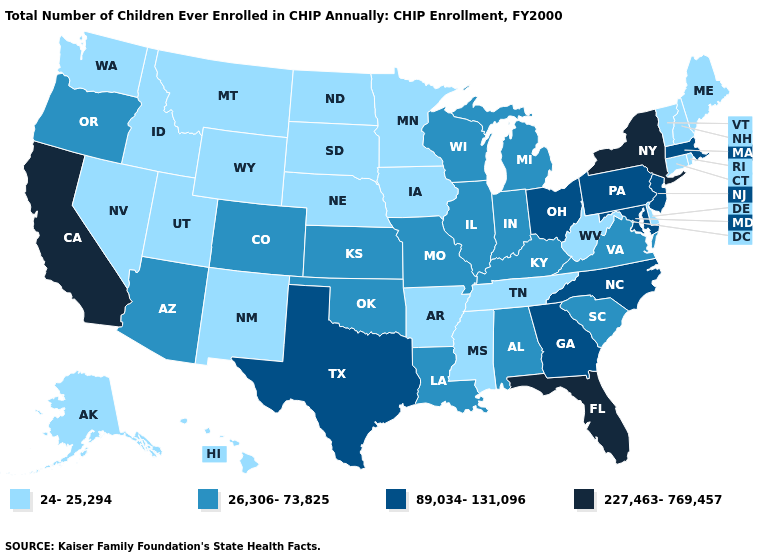Among the states that border Tennessee , does North Carolina have the highest value?
Write a very short answer. Yes. Name the states that have a value in the range 24-25,294?
Concise answer only. Alaska, Arkansas, Connecticut, Delaware, Hawaii, Idaho, Iowa, Maine, Minnesota, Mississippi, Montana, Nebraska, Nevada, New Hampshire, New Mexico, North Dakota, Rhode Island, South Dakota, Tennessee, Utah, Vermont, Washington, West Virginia, Wyoming. What is the lowest value in states that border Iowa?
Write a very short answer. 24-25,294. Does Kansas have the highest value in the MidWest?
Keep it brief. No. What is the value of Maryland?
Be succinct. 89,034-131,096. Does New York have the highest value in the Northeast?
Be succinct. Yes. Does the map have missing data?
Concise answer only. No. What is the value of Virginia?
Keep it brief. 26,306-73,825. Is the legend a continuous bar?
Be succinct. No. What is the lowest value in the USA?
Write a very short answer. 24-25,294. Does New York have a higher value than Wisconsin?
Be succinct. Yes. What is the lowest value in the USA?
Answer briefly. 24-25,294. Does New York have the highest value in the USA?
Keep it brief. Yes. Does the map have missing data?
Be succinct. No. Among the states that border Montana , which have the lowest value?
Keep it brief. Idaho, North Dakota, South Dakota, Wyoming. 